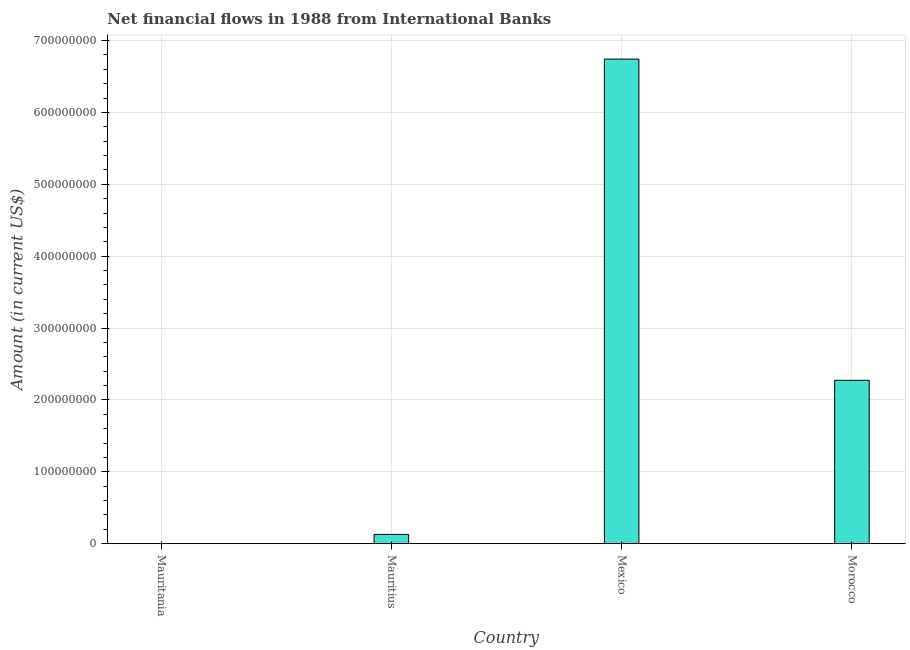Does the graph contain any zero values?
Provide a short and direct response. Yes. What is the title of the graph?
Make the answer very short. Net financial flows in 1988 from International Banks. What is the label or title of the X-axis?
Provide a short and direct response. Country. What is the net financial flows from ibrd in Morocco?
Your answer should be compact. 2.27e+08. Across all countries, what is the maximum net financial flows from ibrd?
Your response must be concise. 6.74e+08. What is the sum of the net financial flows from ibrd?
Offer a very short reply. 9.15e+08. What is the difference between the net financial flows from ibrd in Mauritius and Morocco?
Your answer should be very brief. -2.14e+08. What is the average net financial flows from ibrd per country?
Your answer should be very brief. 2.29e+08. What is the median net financial flows from ibrd?
Provide a succinct answer. 1.20e+08. What is the ratio of the net financial flows from ibrd in Mauritius to that in Morocco?
Provide a succinct answer. 0.06. What is the difference between the highest and the second highest net financial flows from ibrd?
Offer a very short reply. 4.47e+08. What is the difference between the highest and the lowest net financial flows from ibrd?
Your answer should be compact. 6.74e+08. How many bars are there?
Keep it short and to the point. 3. How many countries are there in the graph?
Offer a very short reply. 4. What is the Amount (in current US$) in Mauritius?
Your answer should be compact. 1.30e+07. What is the Amount (in current US$) in Mexico?
Your answer should be compact. 6.74e+08. What is the Amount (in current US$) in Morocco?
Give a very brief answer. 2.27e+08. What is the difference between the Amount (in current US$) in Mauritius and Mexico?
Offer a terse response. -6.61e+08. What is the difference between the Amount (in current US$) in Mauritius and Morocco?
Provide a short and direct response. -2.14e+08. What is the difference between the Amount (in current US$) in Mexico and Morocco?
Keep it short and to the point. 4.47e+08. What is the ratio of the Amount (in current US$) in Mauritius to that in Mexico?
Make the answer very short. 0.02. What is the ratio of the Amount (in current US$) in Mauritius to that in Morocco?
Your answer should be very brief. 0.06. What is the ratio of the Amount (in current US$) in Mexico to that in Morocco?
Provide a short and direct response. 2.96. 